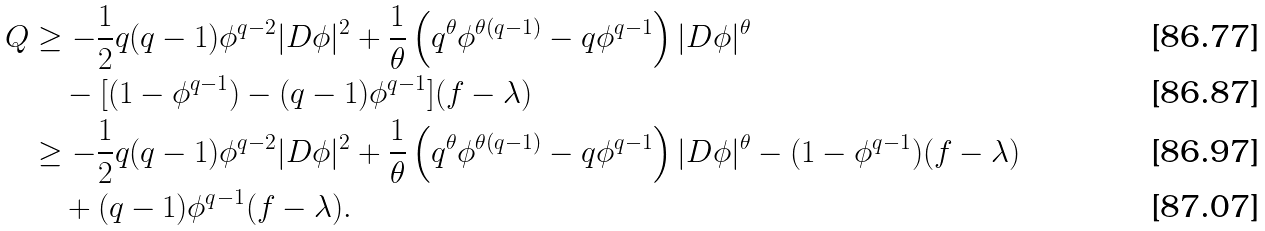Convert formula to latex. <formula><loc_0><loc_0><loc_500><loc_500>Q & \geq - \frac { 1 } { 2 } q ( q - 1 ) \phi ^ { q - 2 } | D \phi | ^ { 2 } + \frac { 1 } { \theta } \left ( q ^ { \theta } \phi ^ { \theta ( q - 1 ) } - q \phi ^ { q - 1 } \right ) | D \phi | ^ { \theta } \\ & \quad - [ ( 1 - \phi ^ { q - 1 } ) - ( q - 1 ) \phi ^ { q - 1 } ] ( f - \lambda ) \\ & \geq - \frac { 1 } { 2 } q ( q - 1 ) \phi ^ { q - 2 } | D \phi | ^ { 2 } + \frac { 1 } { \theta } \left ( q ^ { \theta } \phi ^ { \theta ( q - 1 ) } - q \phi ^ { q - 1 } \right ) | D \phi | ^ { \theta } - ( 1 - \phi ^ { q - 1 } ) ( f - \lambda ) \\ & \quad + ( q - 1 ) \phi ^ { q - 1 } ( f - \lambda ) .</formula> 